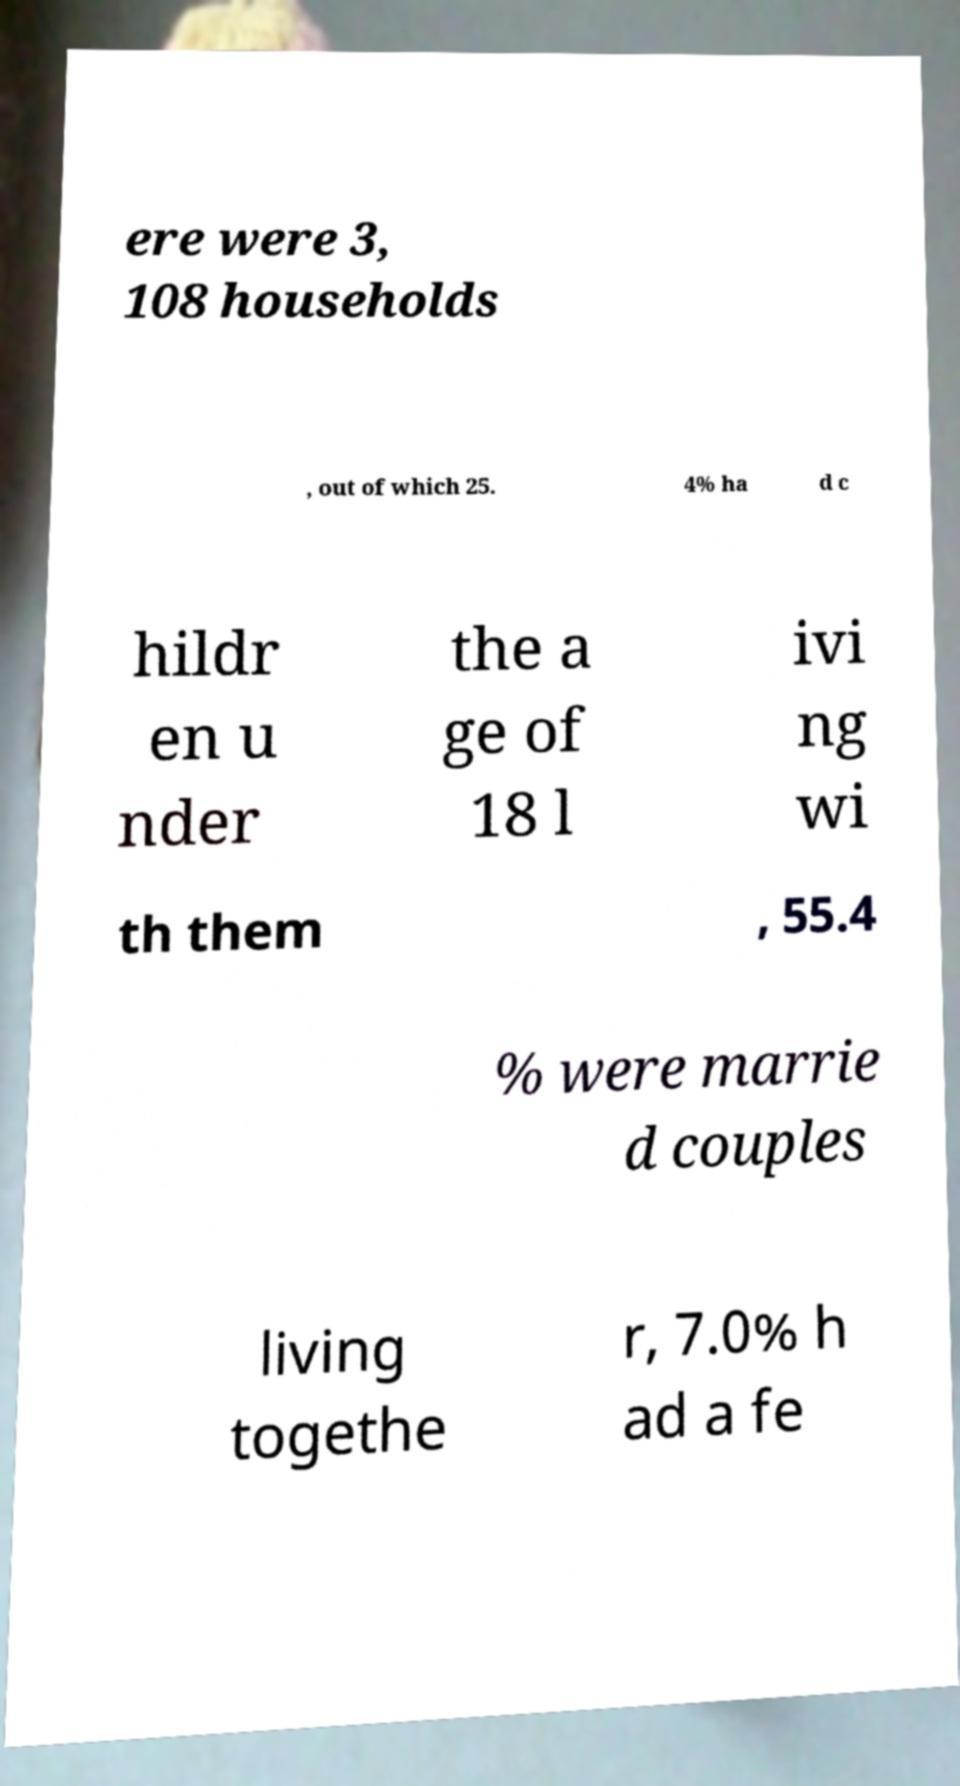Please read and relay the text visible in this image. What does it say? ere were 3, 108 households , out of which 25. 4% ha d c hildr en u nder the a ge of 18 l ivi ng wi th them , 55.4 % were marrie d couples living togethe r, 7.0% h ad a fe 